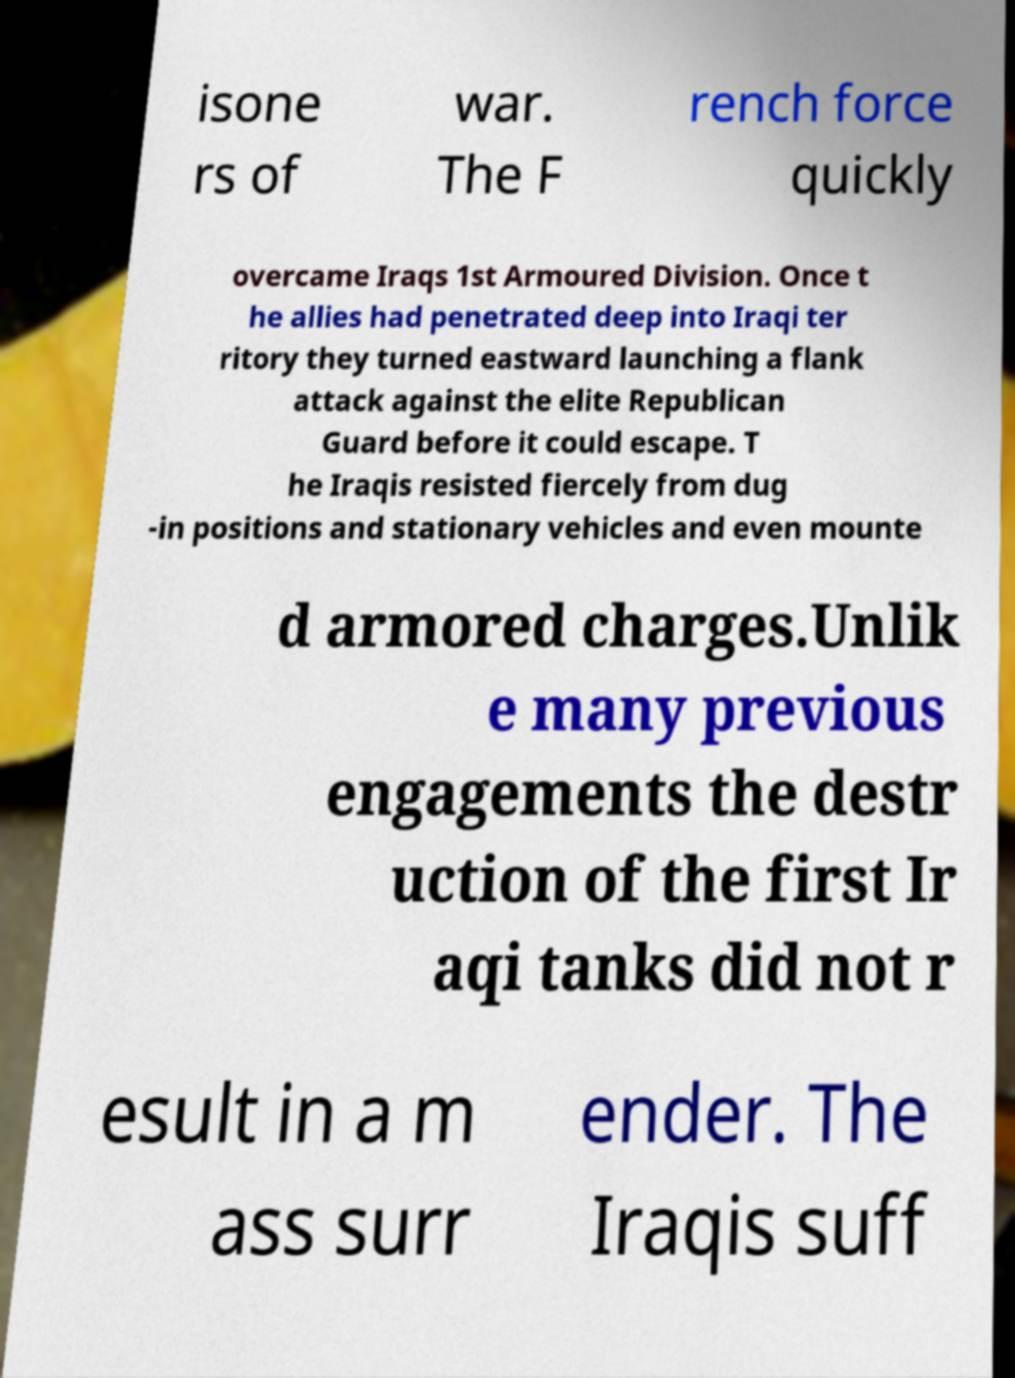Please read and relay the text visible in this image. What does it say? isone rs of war. The F rench force quickly overcame Iraqs 1st Armoured Division. Once t he allies had penetrated deep into Iraqi ter ritory they turned eastward launching a flank attack against the elite Republican Guard before it could escape. T he Iraqis resisted fiercely from dug -in positions and stationary vehicles and even mounte d armored charges.Unlik e many previous engagements the destr uction of the first Ir aqi tanks did not r esult in a m ass surr ender. The Iraqis suff 